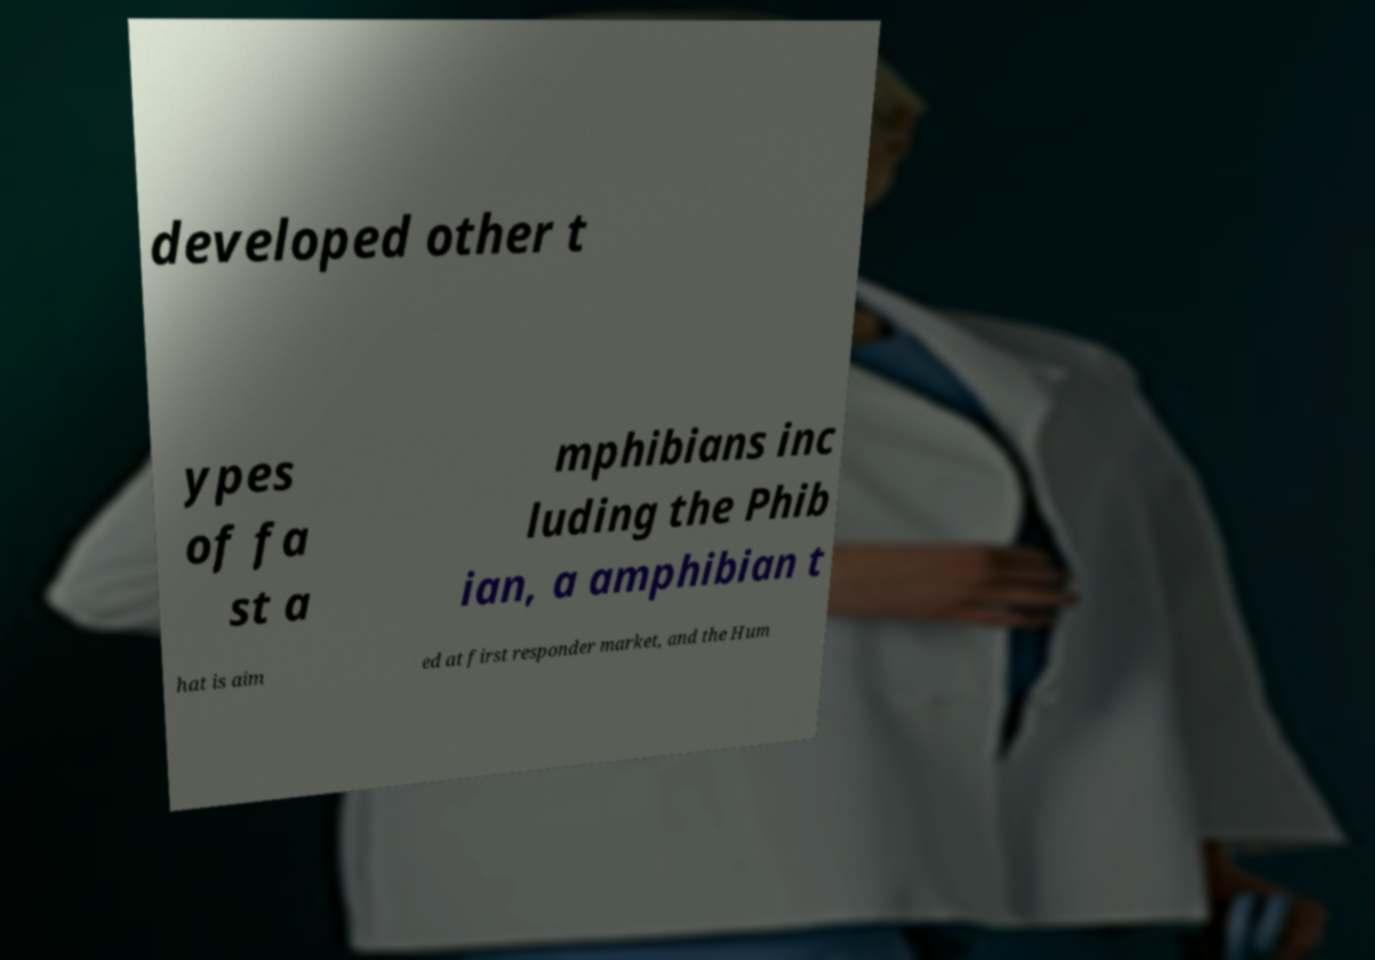Can you accurately transcribe the text from the provided image for me? developed other t ypes of fa st a mphibians inc luding the Phib ian, a amphibian t hat is aim ed at first responder market, and the Hum 